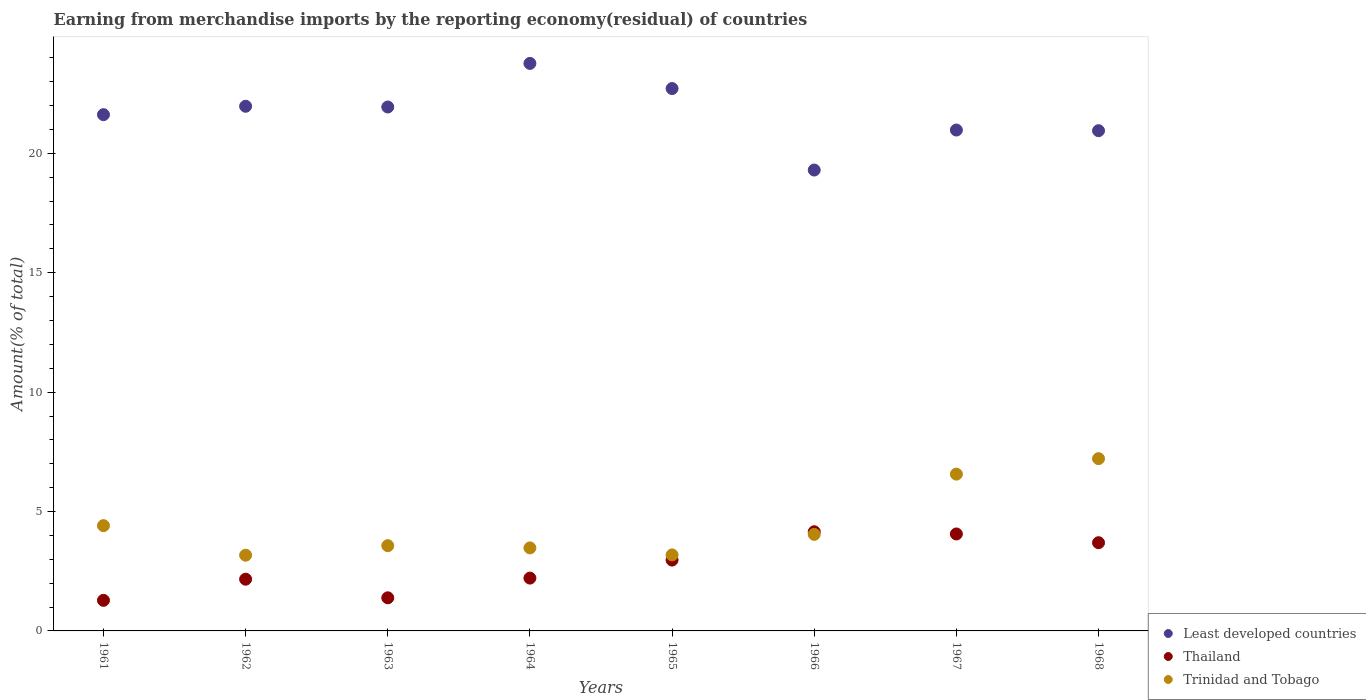How many different coloured dotlines are there?
Make the answer very short. 3. Is the number of dotlines equal to the number of legend labels?
Ensure brevity in your answer.  Yes. What is the percentage of amount earned from merchandise imports in Least developed countries in 1968?
Make the answer very short. 20.95. Across all years, what is the maximum percentage of amount earned from merchandise imports in Trinidad and Tobago?
Your response must be concise. 7.21. Across all years, what is the minimum percentage of amount earned from merchandise imports in Least developed countries?
Keep it short and to the point. 19.3. In which year was the percentage of amount earned from merchandise imports in Trinidad and Tobago maximum?
Your response must be concise. 1968. What is the total percentage of amount earned from merchandise imports in Thailand in the graph?
Give a very brief answer. 21.92. What is the difference between the percentage of amount earned from merchandise imports in Least developed countries in 1961 and that in 1966?
Your answer should be compact. 2.32. What is the difference between the percentage of amount earned from merchandise imports in Least developed countries in 1967 and the percentage of amount earned from merchandise imports in Trinidad and Tobago in 1968?
Your response must be concise. 13.76. What is the average percentage of amount earned from merchandise imports in Least developed countries per year?
Your response must be concise. 21.65. In the year 1961, what is the difference between the percentage of amount earned from merchandise imports in Least developed countries and percentage of amount earned from merchandise imports in Trinidad and Tobago?
Your answer should be compact. 17.21. What is the ratio of the percentage of amount earned from merchandise imports in Thailand in 1965 to that in 1968?
Your answer should be compact. 0.8. Is the difference between the percentage of amount earned from merchandise imports in Least developed countries in 1965 and 1967 greater than the difference between the percentage of amount earned from merchandise imports in Trinidad and Tobago in 1965 and 1967?
Your answer should be compact. Yes. What is the difference between the highest and the second highest percentage of amount earned from merchandise imports in Trinidad and Tobago?
Make the answer very short. 0.65. What is the difference between the highest and the lowest percentage of amount earned from merchandise imports in Thailand?
Offer a very short reply. 2.87. In how many years, is the percentage of amount earned from merchandise imports in Thailand greater than the average percentage of amount earned from merchandise imports in Thailand taken over all years?
Your answer should be very brief. 4. Is the sum of the percentage of amount earned from merchandise imports in Thailand in 1963 and 1965 greater than the maximum percentage of amount earned from merchandise imports in Trinidad and Tobago across all years?
Make the answer very short. No. Does the percentage of amount earned from merchandise imports in Trinidad and Tobago monotonically increase over the years?
Provide a succinct answer. No. How many dotlines are there?
Your answer should be very brief. 3. Does the graph contain any zero values?
Ensure brevity in your answer.  No. How are the legend labels stacked?
Provide a succinct answer. Vertical. What is the title of the graph?
Give a very brief answer. Earning from merchandise imports by the reporting economy(residual) of countries. Does "Liechtenstein" appear as one of the legend labels in the graph?
Offer a terse response. No. What is the label or title of the Y-axis?
Your answer should be very brief. Amount(% of total). What is the Amount(% of total) in Least developed countries in 1961?
Your response must be concise. 21.62. What is the Amount(% of total) of Thailand in 1961?
Offer a terse response. 1.28. What is the Amount(% of total) of Trinidad and Tobago in 1961?
Make the answer very short. 4.41. What is the Amount(% of total) in Least developed countries in 1962?
Provide a short and direct response. 21.97. What is the Amount(% of total) of Thailand in 1962?
Offer a terse response. 2.17. What is the Amount(% of total) in Trinidad and Tobago in 1962?
Your answer should be compact. 3.17. What is the Amount(% of total) in Least developed countries in 1963?
Offer a very short reply. 21.94. What is the Amount(% of total) in Thailand in 1963?
Offer a terse response. 1.39. What is the Amount(% of total) of Trinidad and Tobago in 1963?
Make the answer very short. 3.57. What is the Amount(% of total) of Least developed countries in 1964?
Ensure brevity in your answer.  23.77. What is the Amount(% of total) of Thailand in 1964?
Ensure brevity in your answer.  2.21. What is the Amount(% of total) of Trinidad and Tobago in 1964?
Make the answer very short. 3.48. What is the Amount(% of total) of Least developed countries in 1965?
Offer a very short reply. 22.71. What is the Amount(% of total) in Thailand in 1965?
Keep it short and to the point. 2.97. What is the Amount(% of total) in Trinidad and Tobago in 1965?
Give a very brief answer. 3.18. What is the Amount(% of total) in Least developed countries in 1966?
Provide a succinct answer. 19.3. What is the Amount(% of total) in Thailand in 1966?
Your answer should be very brief. 4.15. What is the Amount(% of total) of Trinidad and Tobago in 1966?
Ensure brevity in your answer.  4.04. What is the Amount(% of total) in Least developed countries in 1967?
Ensure brevity in your answer.  20.98. What is the Amount(% of total) in Thailand in 1967?
Provide a short and direct response. 4.06. What is the Amount(% of total) of Trinidad and Tobago in 1967?
Offer a very short reply. 6.57. What is the Amount(% of total) in Least developed countries in 1968?
Offer a terse response. 20.95. What is the Amount(% of total) in Thailand in 1968?
Make the answer very short. 3.69. What is the Amount(% of total) of Trinidad and Tobago in 1968?
Provide a short and direct response. 7.21. Across all years, what is the maximum Amount(% of total) of Least developed countries?
Provide a short and direct response. 23.77. Across all years, what is the maximum Amount(% of total) in Thailand?
Make the answer very short. 4.15. Across all years, what is the maximum Amount(% of total) in Trinidad and Tobago?
Offer a terse response. 7.21. Across all years, what is the minimum Amount(% of total) of Least developed countries?
Provide a succinct answer. 19.3. Across all years, what is the minimum Amount(% of total) in Thailand?
Your answer should be very brief. 1.28. Across all years, what is the minimum Amount(% of total) in Trinidad and Tobago?
Keep it short and to the point. 3.17. What is the total Amount(% of total) of Least developed countries in the graph?
Provide a succinct answer. 173.23. What is the total Amount(% of total) of Thailand in the graph?
Your answer should be very brief. 21.92. What is the total Amount(% of total) of Trinidad and Tobago in the graph?
Offer a very short reply. 35.63. What is the difference between the Amount(% of total) in Least developed countries in 1961 and that in 1962?
Keep it short and to the point. -0.35. What is the difference between the Amount(% of total) in Thailand in 1961 and that in 1962?
Your response must be concise. -0.89. What is the difference between the Amount(% of total) of Trinidad and Tobago in 1961 and that in 1962?
Your answer should be compact. 1.24. What is the difference between the Amount(% of total) of Least developed countries in 1961 and that in 1963?
Your answer should be very brief. -0.32. What is the difference between the Amount(% of total) in Thailand in 1961 and that in 1963?
Your answer should be very brief. -0.11. What is the difference between the Amount(% of total) in Trinidad and Tobago in 1961 and that in 1963?
Provide a short and direct response. 0.84. What is the difference between the Amount(% of total) of Least developed countries in 1961 and that in 1964?
Provide a succinct answer. -2.15. What is the difference between the Amount(% of total) of Thailand in 1961 and that in 1964?
Ensure brevity in your answer.  -0.93. What is the difference between the Amount(% of total) in Trinidad and Tobago in 1961 and that in 1964?
Your answer should be very brief. 0.93. What is the difference between the Amount(% of total) of Least developed countries in 1961 and that in 1965?
Ensure brevity in your answer.  -1.09. What is the difference between the Amount(% of total) in Thailand in 1961 and that in 1965?
Make the answer very short. -1.69. What is the difference between the Amount(% of total) of Trinidad and Tobago in 1961 and that in 1965?
Your answer should be compact. 1.23. What is the difference between the Amount(% of total) of Least developed countries in 1961 and that in 1966?
Offer a very short reply. 2.32. What is the difference between the Amount(% of total) in Thailand in 1961 and that in 1966?
Your answer should be very brief. -2.87. What is the difference between the Amount(% of total) of Trinidad and Tobago in 1961 and that in 1966?
Ensure brevity in your answer.  0.37. What is the difference between the Amount(% of total) of Least developed countries in 1961 and that in 1967?
Offer a very short reply. 0.64. What is the difference between the Amount(% of total) in Thailand in 1961 and that in 1967?
Your answer should be compact. -2.78. What is the difference between the Amount(% of total) in Trinidad and Tobago in 1961 and that in 1967?
Your answer should be compact. -2.16. What is the difference between the Amount(% of total) of Least developed countries in 1961 and that in 1968?
Your answer should be compact. 0.67. What is the difference between the Amount(% of total) in Thailand in 1961 and that in 1968?
Ensure brevity in your answer.  -2.41. What is the difference between the Amount(% of total) of Trinidad and Tobago in 1961 and that in 1968?
Provide a succinct answer. -2.81. What is the difference between the Amount(% of total) in Least developed countries in 1962 and that in 1963?
Offer a very short reply. 0.03. What is the difference between the Amount(% of total) in Thailand in 1962 and that in 1963?
Offer a terse response. 0.78. What is the difference between the Amount(% of total) in Trinidad and Tobago in 1962 and that in 1963?
Provide a succinct answer. -0.4. What is the difference between the Amount(% of total) in Least developed countries in 1962 and that in 1964?
Offer a very short reply. -1.79. What is the difference between the Amount(% of total) of Thailand in 1962 and that in 1964?
Offer a very short reply. -0.05. What is the difference between the Amount(% of total) of Trinidad and Tobago in 1962 and that in 1964?
Provide a short and direct response. -0.31. What is the difference between the Amount(% of total) of Least developed countries in 1962 and that in 1965?
Your answer should be very brief. -0.74. What is the difference between the Amount(% of total) in Thailand in 1962 and that in 1965?
Offer a terse response. -0.8. What is the difference between the Amount(% of total) in Trinidad and Tobago in 1962 and that in 1965?
Your answer should be compact. -0.01. What is the difference between the Amount(% of total) of Least developed countries in 1962 and that in 1966?
Offer a terse response. 2.67. What is the difference between the Amount(% of total) in Thailand in 1962 and that in 1966?
Your answer should be very brief. -1.99. What is the difference between the Amount(% of total) of Trinidad and Tobago in 1962 and that in 1966?
Make the answer very short. -0.87. What is the difference between the Amount(% of total) in Least developed countries in 1962 and that in 1967?
Keep it short and to the point. 1. What is the difference between the Amount(% of total) of Thailand in 1962 and that in 1967?
Your answer should be compact. -1.89. What is the difference between the Amount(% of total) of Trinidad and Tobago in 1962 and that in 1967?
Offer a terse response. -3.4. What is the difference between the Amount(% of total) in Least developed countries in 1962 and that in 1968?
Ensure brevity in your answer.  1.02. What is the difference between the Amount(% of total) in Thailand in 1962 and that in 1968?
Your response must be concise. -1.53. What is the difference between the Amount(% of total) in Trinidad and Tobago in 1962 and that in 1968?
Ensure brevity in your answer.  -4.04. What is the difference between the Amount(% of total) of Least developed countries in 1963 and that in 1964?
Provide a succinct answer. -1.82. What is the difference between the Amount(% of total) of Thailand in 1963 and that in 1964?
Provide a short and direct response. -0.83. What is the difference between the Amount(% of total) in Trinidad and Tobago in 1963 and that in 1964?
Make the answer very short. 0.09. What is the difference between the Amount(% of total) of Least developed countries in 1963 and that in 1965?
Keep it short and to the point. -0.77. What is the difference between the Amount(% of total) of Thailand in 1963 and that in 1965?
Offer a very short reply. -1.58. What is the difference between the Amount(% of total) in Trinidad and Tobago in 1963 and that in 1965?
Make the answer very short. 0.39. What is the difference between the Amount(% of total) of Least developed countries in 1963 and that in 1966?
Provide a succinct answer. 2.64. What is the difference between the Amount(% of total) of Thailand in 1963 and that in 1966?
Give a very brief answer. -2.77. What is the difference between the Amount(% of total) in Trinidad and Tobago in 1963 and that in 1966?
Provide a succinct answer. -0.47. What is the difference between the Amount(% of total) of Least developed countries in 1963 and that in 1967?
Your response must be concise. 0.96. What is the difference between the Amount(% of total) of Thailand in 1963 and that in 1967?
Make the answer very short. -2.67. What is the difference between the Amount(% of total) in Trinidad and Tobago in 1963 and that in 1967?
Your answer should be very brief. -3. What is the difference between the Amount(% of total) of Thailand in 1963 and that in 1968?
Keep it short and to the point. -2.31. What is the difference between the Amount(% of total) of Trinidad and Tobago in 1963 and that in 1968?
Your response must be concise. -3.64. What is the difference between the Amount(% of total) of Least developed countries in 1964 and that in 1965?
Give a very brief answer. 1.05. What is the difference between the Amount(% of total) in Thailand in 1964 and that in 1965?
Make the answer very short. -0.75. What is the difference between the Amount(% of total) of Trinidad and Tobago in 1964 and that in 1965?
Your answer should be compact. 0.29. What is the difference between the Amount(% of total) of Least developed countries in 1964 and that in 1966?
Ensure brevity in your answer.  4.46. What is the difference between the Amount(% of total) of Thailand in 1964 and that in 1966?
Offer a terse response. -1.94. What is the difference between the Amount(% of total) of Trinidad and Tobago in 1964 and that in 1966?
Your response must be concise. -0.57. What is the difference between the Amount(% of total) of Least developed countries in 1964 and that in 1967?
Offer a terse response. 2.79. What is the difference between the Amount(% of total) in Thailand in 1964 and that in 1967?
Provide a succinct answer. -1.85. What is the difference between the Amount(% of total) in Trinidad and Tobago in 1964 and that in 1967?
Your answer should be compact. -3.09. What is the difference between the Amount(% of total) in Least developed countries in 1964 and that in 1968?
Offer a very short reply. 2.82. What is the difference between the Amount(% of total) in Thailand in 1964 and that in 1968?
Provide a succinct answer. -1.48. What is the difference between the Amount(% of total) of Trinidad and Tobago in 1964 and that in 1968?
Provide a short and direct response. -3.74. What is the difference between the Amount(% of total) in Least developed countries in 1965 and that in 1966?
Give a very brief answer. 3.41. What is the difference between the Amount(% of total) in Thailand in 1965 and that in 1966?
Offer a terse response. -1.19. What is the difference between the Amount(% of total) in Trinidad and Tobago in 1965 and that in 1966?
Your answer should be very brief. -0.86. What is the difference between the Amount(% of total) of Least developed countries in 1965 and that in 1967?
Ensure brevity in your answer.  1.74. What is the difference between the Amount(% of total) of Thailand in 1965 and that in 1967?
Your answer should be compact. -1.09. What is the difference between the Amount(% of total) of Trinidad and Tobago in 1965 and that in 1967?
Make the answer very short. -3.38. What is the difference between the Amount(% of total) of Least developed countries in 1965 and that in 1968?
Your answer should be very brief. 1.77. What is the difference between the Amount(% of total) in Thailand in 1965 and that in 1968?
Offer a terse response. -0.73. What is the difference between the Amount(% of total) of Trinidad and Tobago in 1965 and that in 1968?
Keep it short and to the point. -4.03. What is the difference between the Amount(% of total) in Least developed countries in 1966 and that in 1967?
Keep it short and to the point. -1.67. What is the difference between the Amount(% of total) of Thailand in 1966 and that in 1967?
Make the answer very short. 0.09. What is the difference between the Amount(% of total) of Trinidad and Tobago in 1966 and that in 1967?
Provide a short and direct response. -2.52. What is the difference between the Amount(% of total) of Least developed countries in 1966 and that in 1968?
Provide a succinct answer. -1.65. What is the difference between the Amount(% of total) in Thailand in 1966 and that in 1968?
Your answer should be compact. 0.46. What is the difference between the Amount(% of total) in Trinidad and Tobago in 1966 and that in 1968?
Provide a succinct answer. -3.17. What is the difference between the Amount(% of total) of Least developed countries in 1967 and that in 1968?
Your answer should be very brief. 0.03. What is the difference between the Amount(% of total) in Thailand in 1967 and that in 1968?
Offer a very short reply. 0.37. What is the difference between the Amount(% of total) of Trinidad and Tobago in 1967 and that in 1968?
Your answer should be compact. -0.65. What is the difference between the Amount(% of total) of Least developed countries in 1961 and the Amount(% of total) of Thailand in 1962?
Offer a terse response. 19.45. What is the difference between the Amount(% of total) in Least developed countries in 1961 and the Amount(% of total) in Trinidad and Tobago in 1962?
Offer a very short reply. 18.45. What is the difference between the Amount(% of total) of Thailand in 1961 and the Amount(% of total) of Trinidad and Tobago in 1962?
Provide a short and direct response. -1.89. What is the difference between the Amount(% of total) of Least developed countries in 1961 and the Amount(% of total) of Thailand in 1963?
Offer a very short reply. 20.23. What is the difference between the Amount(% of total) of Least developed countries in 1961 and the Amount(% of total) of Trinidad and Tobago in 1963?
Your answer should be very brief. 18.05. What is the difference between the Amount(% of total) of Thailand in 1961 and the Amount(% of total) of Trinidad and Tobago in 1963?
Ensure brevity in your answer.  -2.29. What is the difference between the Amount(% of total) of Least developed countries in 1961 and the Amount(% of total) of Thailand in 1964?
Keep it short and to the point. 19.41. What is the difference between the Amount(% of total) in Least developed countries in 1961 and the Amount(% of total) in Trinidad and Tobago in 1964?
Make the answer very short. 18.14. What is the difference between the Amount(% of total) of Thailand in 1961 and the Amount(% of total) of Trinidad and Tobago in 1964?
Make the answer very short. -2.2. What is the difference between the Amount(% of total) in Least developed countries in 1961 and the Amount(% of total) in Thailand in 1965?
Make the answer very short. 18.65. What is the difference between the Amount(% of total) of Least developed countries in 1961 and the Amount(% of total) of Trinidad and Tobago in 1965?
Give a very brief answer. 18.44. What is the difference between the Amount(% of total) in Thailand in 1961 and the Amount(% of total) in Trinidad and Tobago in 1965?
Offer a terse response. -1.9. What is the difference between the Amount(% of total) in Least developed countries in 1961 and the Amount(% of total) in Thailand in 1966?
Offer a very short reply. 17.47. What is the difference between the Amount(% of total) in Least developed countries in 1961 and the Amount(% of total) in Trinidad and Tobago in 1966?
Offer a very short reply. 17.58. What is the difference between the Amount(% of total) of Thailand in 1961 and the Amount(% of total) of Trinidad and Tobago in 1966?
Offer a terse response. -2.76. What is the difference between the Amount(% of total) in Least developed countries in 1961 and the Amount(% of total) in Thailand in 1967?
Offer a very short reply. 17.56. What is the difference between the Amount(% of total) in Least developed countries in 1961 and the Amount(% of total) in Trinidad and Tobago in 1967?
Make the answer very short. 15.05. What is the difference between the Amount(% of total) in Thailand in 1961 and the Amount(% of total) in Trinidad and Tobago in 1967?
Ensure brevity in your answer.  -5.29. What is the difference between the Amount(% of total) of Least developed countries in 1961 and the Amount(% of total) of Thailand in 1968?
Offer a terse response. 17.93. What is the difference between the Amount(% of total) of Least developed countries in 1961 and the Amount(% of total) of Trinidad and Tobago in 1968?
Provide a short and direct response. 14.41. What is the difference between the Amount(% of total) of Thailand in 1961 and the Amount(% of total) of Trinidad and Tobago in 1968?
Ensure brevity in your answer.  -5.93. What is the difference between the Amount(% of total) in Least developed countries in 1962 and the Amount(% of total) in Thailand in 1963?
Ensure brevity in your answer.  20.58. What is the difference between the Amount(% of total) in Least developed countries in 1962 and the Amount(% of total) in Trinidad and Tobago in 1963?
Your answer should be compact. 18.4. What is the difference between the Amount(% of total) of Thailand in 1962 and the Amount(% of total) of Trinidad and Tobago in 1963?
Offer a very short reply. -1.4. What is the difference between the Amount(% of total) in Least developed countries in 1962 and the Amount(% of total) in Thailand in 1964?
Offer a very short reply. 19.76. What is the difference between the Amount(% of total) of Least developed countries in 1962 and the Amount(% of total) of Trinidad and Tobago in 1964?
Ensure brevity in your answer.  18.49. What is the difference between the Amount(% of total) in Thailand in 1962 and the Amount(% of total) in Trinidad and Tobago in 1964?
Your response must be concise. -1.31. What is the difference between the Amount(% of total) in Least developed countries in 1962 and the Amount(% of total) in Thailand in 1965?
Offer a very short reply. 19. What is the difference between the Amount(% of total) in Least developed countries in 1962 and the Amount(% of total) in Trinidad and Tobago in 1965?
Give a very brief answer. 18.79. What is the difference between the Amount(% of total) of Thailand in 1962 and the Amount(% of total) of Trinidad and Tobago in 1965?
Give a very brief answer. -1.02. What is the difference between the Amount(% of total) of Least developed countries in 1962 and the Amount(% of total) of Thailand in 1966?
Provide a succinct answer. 17.82. What is the difference between the Amount(% of total) in Least developed countries in 1962 and the Amount(% of total) in Trinidad and Tobago in 1966?
Provide a short and direct response. 17.93. What is the difference between the Amount(% of total) of Thailand in 1962 and the Amount(% of total) of Trinidad and Tobago in 1966?
Make the answer very short. -1.88. What is the difference between the Amount(% of total) in Least developed countries in 1962 and the Amount(% of total) in Thailand in 1967?
Provide a short and direct response. 17.91. What is the difference between the Amount(% of total) of Least developed countries in 1962 and the Amount(% of total) of Trinidad and Tobago in 1967?
Your answer should be compact. 15.4. What is the difference between the Amount(% of total) of Thailand in 1962 and the Amount(% of total) of Trinidad and Tobago in 1967?
Offer a terse response. -4.4. What is the difference between the Amount(% of total) in Least developed countries in 1962 and the Amount(% of total) in Thailand in 1968?
Offer a terse response. 18.28. What is the difference between the Amount(% of total) of Least developed countries in 1962 and the Amount(% of total) of Trinidad and Tobago in 1968?
Make the answer very short. 14.76. What is the difference between the Amount(% of total) in Thailand in 1962 and the Amount(% of total) in Trinidad and Tobago in 1968?
Offer a terse response. -5.05. What is the difference between the Amount(% of total) in Least developed countries in 1963 and the Amount(% of total) in Thailand in 1964?
Your response must be concise. 19.73. What is the difference between the Amount(% of total) in Least developed countries in 1963 and the Amount(% of total) in Trinidad and Tobago in 1964?
Keep it short and to the point. 18.46. What is the difference between the Amount(% of total) of Thailand in 1963 and the Amount(% of total) of Trinidad and Tobago in 1964?
Your response must be concise. -2.09. What is the difference between the Amount(% of total) in Least developed countries in 1963 and the Amount(% of total) in Thailand in 1965?
Ensure brevity in your answer.  18.97. What is the difference between the Amount(% of total) in Least developed countries in 1963 and the Amount(% of total) in Trinidad and Tobago in 1965?
Your response must be concise. 18.76. What is the difference between the Amount(% of total) of Thailand in 1963 and the Amount(% of total) of Trinidad and Tobago in 1965?
Offer a terse response. -1.8. What is the difference between the Amount(% of total) of Least developed countries in 1963 and the Amount(% of total) of Thailand in 1966?
Make the answer very short. 17.79. What is the difference between the Amount(% of total) of Least developed countries in 1963 and the Amount(% of total) of Trinidad and Tobago in 1966?
Offer a very short reply. 17.9. What is the difference between the Amount(% of total) of Thailand in 1963 and the Amount(% of total) of Trinidad and Tobago in 1966?
Keep it short and to the point. -2.66. What is the difference between the Amount(% of total) of Least developed countries in 1963 and the Amount(% of total) of Thailand in 1967?
Keep it short and to the point. 17.88. What is the difference between the Amount(% of total) in Least developed countries in 1963 and the Amount(% of total) in Trinidad and Tobago in 1967?
Offer a very short reply. 15.37. What is the difference between the Amount(% of total) in Thailand in 1963 and the Amount(% of total) in Trinidad and Tobago in 1967?
Your answer should be very brief. -5.18. What is the difference between the Amount(% of total) in Least developed countries in 1963 and the Amount(% of total) in Thailand in 1968?
Offer a very short reply. 18.25. What is the difference between the Amount(% of total) of Least developed countries in 1963 and the Amount(% of total) of Trinidad and Tobago in 1968?
Offer a very short reply. 14.73. What is the difference between the Amount(% of total) in Thailand in 1963 and the Amount(% of total) in Trinidad and Tobago in 1968?
Keep it short and to the point. -5.83. What is the difference between the Amount(% of total) in Least developed countries in 1964 and the Amount(% of total) in Thailand in 1965?
Give a very brief answer. 20.8. What is the difference between the Amount(% of total) in Least developed countries in 1964 and the Amount(% of total) in Trinidad and Tobago in 1965?
Offer a very short reply. 20.58. What is the difference between the Amount(% of total) of Thailand in 1964 and the Amount(% of total) of Trinidad and Tobago in 1965?
Your response must be concise. -0.97. What is the difference between the Amount(% of total) of Least developed countries in 1964 and the Amount(% of total) of Thailand in 1966?
Provide a succinct answer. 19.61. What is the difference between the Amount(% of total) in Least developed countries in 1964 and the Amount(% of total) in Trinidad and Tobago in 1966?
Offer a terse response. 19.72. What is the difference between the Amount(% of total) in Thailand in 1964 and the Amount(% of total) in Trinidad and Tobago in 1966?
Provide a short and direct response. -1.83. What is the difference between the Amount(% of total) of Least developed countries in 1964 and the Amount(% of total) of Thailand in 1967?
Your response must be concise. 19.71. What is the difference between the Amount(% of total) of Least developed countries in 1964 and the Amount(% of total) of Trinidad and Tobago in 1967?
Your answer should be very brief. 17.2. What is the difference between the Amount(% of total) of Thailand in 1964 and the Amount(% of total) of Trinidad and Tobago in 1967?
Offer a terse response. -4.35. What is the difference between the Amount(% of total) in Least developed countries in 1964 and the Amount(% of total) in Thailand in 1968?
Ensure brevity in your answer.  20.07. What is the difference between the Amount(% of total) of Least developed countries in 1964 and the Amount(% of total) of Trinidad and Tobago in 1968?
Your answer should be compact. 16.55. What is the difference between the Amount(% of total) in Thailand in 1964 and the Amount(% of total) in Trinidad and Tobago in 1968?
Keep it short and to the point. -5. What is the difference between the Amount(% of total) in Least developed countries in 1965 and the Amount(% of total) in Thailand in 1966?
Offer a terse response. 18.56. What is the difference between the Amount(% of total) in Least developed countries in 1965 and the Amount(% of total) in Trinidad and Tobago in 1966?
Offer a very short reply. 18.67. What is the difference between the Amount(% of total) in Thailand in 1965 and the Amount(% of total) in Trinidad and Tobago in 1966?
Your answer should be compact. -1.08. What is the difference between the Amount(% of total) of Least developed countries in 1965 and the Amount(% of total) of Thailand in 1967?
Your response must be concise. 18.65. What is the difference between the Amount(% of total) in Least developed countries in 1965 and the Amount(% of total) in Trinidad and Tobago in 1967?
Provide a short and direct response. 16.15. What is the difference between the Amount(% of total) in Thailand in 1965 and the Amount(% of total) in Trinidad and Tobago in 1967?
Make the answer very short. -3.6. What is the difference between the Amount(% of total) of Least developed countries in 1965 and the Amount(% of total) of Thailand in 1968?
Provide a short and direct response. 19.02. What is the difference between the Amount(% of total) of Least developed countries in 1965 and the Amount(% of total) of Trinidad and Tobago in 1968?
Provide a short and direct response. 15.5. What is the difference between the Amount(% of total) of Thailand in 1965 and the Amount(% of total) of Trinidad and Tobago in 1968?
Provide a short and direct response. -4.25. What is the difference between the Amount(% of total) in Least developed countries in 1966 and the Amount(% of total) in Thailand in 1967?
Give a very brief answer. 15.24. What is the difference between the Amount(% of total) in Least developed countries in 1966 and the Amount(% of total) in Trinidad and Tobago in 1967?
Your response must be concise. 12.73. What is the difference between the Amount(% of total) in Thailand in 1966 and the Amount(% of total) in Trinidad and Tobago in 1967?
Keep it short and to the point. -2.41. What is the difference between the Amount(% of total) in Least developed countries in 1966 and the Amount(% of total) in Thailand in 1968?
Keep it short and to the point. 15.61. What is the difference between the Amount(% of total) of Least developed countries in 1966 and the Amount(% of total) of Trinidad and Tobago in 1968?
Your answer should be very brief. 12.09. What is the difference between the Amount(% of total) in Thailand in 1966 and the Amount(% of total) in Trinidad and Tobago in 1968?
Make the answer very short. -3.06. What is the difference between the Amount(% of total) in Least developed countries in 1967 and the Amount(% of total) in Thailand in 1968?
Provide a succinct answer. 17.28. What is the difference between the Amount(% of total) of Least developed countries in 1967 and the Amount(% of total) of Trinidad and Tobago in 1968?
Make the answer very short. 13.76. What is the difference between the Amount(% of total) in Thailand in 1967 and the Amount(% of total) in Trinidad and Tobago in 1968?
Provide a short and direct response. -3.15. What is the average Amount(% of total) of Least developed countries per year?
Give a very brief answer. 21.65. What is the average Amount(% of total) of Thailand per year?
Provide a short and direct response. 2.74. What is the average Amount(% of total) of Trinidad and Tobago per year?
Your answer should be very brief. 4.45. In the year 1961, what is the difference between the Amount(% of total) of Least developed countries and Amount(% of total) of Thailand?
Offer a very short reply. 20.34. In the year 1961, what is the difference between the Amount(% of total) of Least developed countries and Amount(% of total) of Trinidad and Tobago?
Offer a terse response. 17.21. In the year 1961, what is the difference between the Amount(% of total) of Thailand and Amount(% of total) of Trinidad and Tobago?
Give a very brief answer. -3.13. In the year 1962, what is the difference between the Amount(% of total) in Least developed countries and Amount(% of total) in Thailand?
Offer a very short reply. 19.8. In the year 1962, what is the difference between the Amount(% of total) in Least developed countries and Amount(% of total) in Trinidad and Tobago?
Make the answer very short. 18.8. In the year 1962, what is the difference between the Amount(% of total) of Thailand and Amount(% of total) of Trinidad and Tobago?
Provide a short and direct response. -1. In the year 1963, what is the difference between the Amount(% of total) in Least developed countries and Amount(% of total) in Thailand?
Your answer should be compact. 20.55. In the year 1963, what is the difference between the Amount(% of total) in Least developed countries and Amount(% of total) in Trinidad and Tobago?
Keep it short and to the point. 18.37. In the year 1963, what is the difference between the Amount(% of total) in Thailand and Amount(% of total) in Trinidad and Tobago?
Your answer should be very brief. -2.18. In the year 1964, what is the difference between the Amount(% of total) in Least developed countries and Amount(% of total) in Thailand?
Give a very brief answer. 21.55. In the year 1964, what is the difference between the Amount(% of total) of Least developed countries and Amount(% of total) of Trinidad and Tobago?
Ensure brevity in your answer.  20.29. In the year 1964, what is the difference between the Amount(% of total) in Thailand and Amount(% of total) in Trinidad and Tobago?
Make the answer very short. -1.26. In the year 1965, what is the difference between the Amount(% of total) of Least developed countries and Amount(% of total) of Thailand?
Provide a short and direct response. 19.75. In the year 1965, what is the difference between the Amount(% of total) in Least developed countries and Amount(% of total) in Trinidad and Tobago?
Make the answer very short. 19.53. In the year 1965, what is the difference between the Amount(% of total) in Thailand and Amount(% of total) in Trinidad and Tobago?
Offer a very short reply. -0.22. In the year 1966, what is the difference between the Amount(% of total) of Least developed countries and Amount(% of total) of Thailand?
Your answer should be very brief. 15.15. In the year 1966, what is the difference between the Amount(% of total) of Least developed countries and Amount(% of total) of Trinidad and Tobago?
Your answer should be compact. 15.26. In the year 1966, what is the difference between the Amount(% of total) in Thailand and Amount(% of total) in Trinidad and Tobago?
Keep it short and to the point. 0.11. In the year 1967, what is the difference between the Amount(% of total) in Least developed countries and Amount(% of total) in Thailand?
Your answer should be very brief. 16.92. In the year 1967, what is the difference between the Amount(% of total) of Least developed countries and Amount(% of total) of Trinidad and Tobago?
Provide a short and direct response. 14.41. In the year 1967, what is the difference between the Amount(% of total) of Thailand and Amount(% of total) of Trinidad and Tobago?
Your response must be concise. -2.51. In the year 1968, what is the difference between the Amount(% of total) in Least developed countries and Amount(% of total) in Thailand?
Offer a terse response. 17.25. In the year 1968, what is the difference between the Amount(% of total) of Least developed countries and Amount(% of total) of Trinidad and Tobago?
Keep it short and to the point. 13.73. In the year 1968, what is the difference between the Amount(% of total) in Thailand and Amount(% of total) in Trinidad and Tobago?
Ensure brevity in your answer.  -3.52. What is the ratio of the Amount(% of total) in Least developed countries in 1961 to that in 1962?
Your answer should be very brief. 0.98. What is the ratio of the Amount(% of total) of Thailand in 1961 to that in 1962?
Your answer should be very brief. 0.59. What is the ratio of the Amount(% of total) of Trinidad and Tobago in 1961 to that in 1962?
Give a very brief answer. 1.39. What is the ratio of the Amount(% of total) in Least developed countries in 1961 to that in 1963?
Provide a short and direct response. 0.99. What is the ratio of the Amount(% of total) in Thailand in 1961 to that in 1963?
Your answer should be very brief. 0.92. What is the ratio of the Amount(% of total) of Trinidad and Tobago in 1961 to that in 1963?
Offer a very short reply. 1.24. What is the ratio of the Amount(% of total) of Least developed countries in 1961 to that in 1964?
Ensure brevity in your answer.  0.91. What is the ratio of the Amount(% of total) of Thailand in 1961 to that in 1964?
Ensure brevity in your answer.  0.58. What is the ratio of the Amount(% of total) of Trinidad and Tobago in 1961 to that in 1964?
Give a very brief answer. 1.27. What is the ratio of the Amount(% of total) of Least developed countries in 1961 to that in 1965?
Ensure brevity in your answer.  0.95. What is the ratio of the Amount(% of total) in Thailand in 1961 to that in 1965?
Provide a short and direct response. 0.43. What is the ratio of the Amount(% of total) in Trinidad and Tobago in 1961 to that in 1965?
Your answer should be very brief. 1.39. What is the ratio of the Amount(% of total) of Least developed countries in 1961 to that in 1966?
Make the answer very short. 1.12. What is the ratio of the Amount(% of total) in Thailand in 1961 to that in 1966?
Offer a very short reply. 0.31. What is the ratio of the Amount(% of total) in Trinidad and Tobago in 1961 to that in 1966?
Provide a succinct answer. 1.09. What is the ratio of the Amount(% of total) of Least developed countries in 1961 to that in 1967?
Offer a terse response. 1.03. What is the ratio of the Amount(% of total) of Thailand in 1961 to that in 1967?
Your response must be concise. 0.32. What is the ratio of the Amount(% of total) of Trinidad and Tobago in 1961 to that in 1967?
Offer a very short reply. 0.67. What is the ratio of the Amount(% of total) in Least developed countries in 1961 to that in 1968?
Ensure brevity in your answer.  1.03. What is the ratio of the Amount(% of total) of Thailand in 1961 to that in 1968?
Provide a short and direct response. 0.35. What is the ratio of the Amount(% of total) in Trinidad and Tobago in 1961 to that in 1968?
Your answer should be very brief. 0.61. What is the ratio of the Amount(% of total) of Least developed countries in 1962 to that in 1963?
Offer a terse response. 1. What is the ratio of the Amount(% of total) of Thailand in 1962 to that in 1963?
Offer a terse response. 1.56. What is the ratio of the Amount(% of total) of Trinidad and Tobago in 1962 to that in 1963?
Your answer should be compact. 0.89. What is the ratio of the Amount(% of total) of Least developed countries in 1962 to that in 1964?
Your answer should be compact. 0.92. What is the ratio of the Amount(% of total) of Thailand in 1962 to that in 1964?
Your response must be concise. 0.98. What is the ratio of the Amount(% of total) in Trinidad and Tobago in 1962 to that in 1964?
Ensure brevity in your answer.  0.91. What is the ratio of the Amount(% of total) in Least developed countries in 1962 to that in 1965?
Keep it short and to the point. 0.97. What is the ratio of the Amount(% of total) of Thailand in 1962 to that in 1965?
Keep it short and to the point. 0.73. What is the ratio of the Amount(% of total) in Trinidad and Tobago in 1962 to that in 1965?
Ensure brevity in your answer.  1. What is the ratio of the Amount(% of total) of Least developed countries in 1962 to that in 1966?
Your answer should be very brief. 1.14. What is the ratio of the Amount(% of total) in Thailand in 1962 to that in 1966?
Provide a short and direct response. 0.52. What is the ratio of the Amount(% of total) in Trinidad and Tobago in 1962 to that in 1966?
Offer a terse response. 0.78. What is the ratio of the Amount(% of total) of Least developed countries in 1962 to that in 1967?
Your response must be concise. 1.05. What is the ratio of the Amount(% of total) in Thailand in 1962 to that in 1967?
Provide a short and direct response. 0.53. What is the ratio of the Amount(% of total) in Trinidad and Tobago in 1962 to that in 1967?
Ensure brevity in your answer.  0.48. What is the ratio of the Amount(% of total) of Least developed countries in 1962 to that in 1968?
Make the answer very short. 1.05. What is the ratio of the Amount(% of total) of Thailand in 1962 to that in 1968?
Give a very brief answer. 0.59. What is the ratio of the Amount(% of total) of Trinidad and Tobago in 1962 to that in 1968?
Your answer should be very brief. 0.44. What is the ratio of the Amount(% of total) of Least developed countries in 1963 to that in 1964?
Give a very brief answer. 0.92. What is the ratio of the Amount(% of total) in Thailand in 1963 to that in 1964?
Give a very brief answer. 0.63. What is the ratio of the Amount(% of total) in Trinidad and Tobago in 1963 to that in 1964?
Keep it short and to the point. 1.03. What is the ratio of the Amount(% of total) of Thailand in 1963 to that in 1965?
Ensure brevity in your answer.  0.47. What is the ratio of the Amount(% of total) in Trinidad and Tobago in 1963 to that in 1965?
Keep it short and to the point. 1.12. What is the ratio of the Amount(% of total) in Least developed countries in 1963 to that in 1966?
Keep it short and to the point. 1.14. What is the ratio of the Amount(% of total) of Thailand in 1963 to that in 1966?
Offer a terse response. 0.33. What is the ratio of the Amount(% of total) of Trinidad and Tobago in 1963 to that in 1966?
Your answer should be compact. 0.88. What is the ratio of the Amount(% of total) of Least developed countries in 1963 to that in 1967?
Your answer should be very brief. 1.05. What is the ratio of the Amount(% of total) in Thailand in 1963 to that in 1967?
Your answer should be compact. 0.34. What is the ratio of the Amount(% of total) in Trinidad and Tobago in 1963 to that in 1967?
Ensure brevity in your answer.  0.54. What is the ratio of the Amount(% of total) of Least developed countries in 1963 to that in 1968?
Your answer should be very brief. 1.05. What is the ratio of the Amount(% of total) of Thailand in 1963 to that in 1968?
Offer a terse response. 0.38. What is the ratio of the Amount(% of total) of Trinidad and Tobago in 1963 to that in 1968?
Keep it short and to the point. 0.49. What is the ratio of the Amount(% of total) in Least developed countries in 1964 to that in 1965?
Make the answer very short. 1.05. What is the ratio of the Amount(% of total) in Thailand in 1964 to that in 1965?
Provide a succinct answer. 0.75. What is the ratio of the Amount(% of total) of Trinidad and Tobago in 1964 to that in 1965?
Offer a very short reply. 1.09. What is the ratio of the Amount(% of total) of Least developed countries in 1964 to that in 1966?
Provide a succinct answer. 1.23. What is the ratio of the Amount(% of total) of Thailand in 1964 to that in 1966?
Your answer should be very brief. 0.53. What is the ratio of the Amount(% of total) in Trinidad and Tobago in 1964 to that in 1966?
Make the answer very short. 0.86. What is the ratio of the Amount(% of total) in Least developed countries in 1964 to that in 1967?
Ensure brevity in your answer.  1.13. What is the ratio of the Amount(% of total) of Thailand in 1964 to that in 1967?
Ensure brevity in your answer.  0.54. What is the ratio of the Amount(% of total) in Trinidad and Tobago in 1964 to that in 1967?
Give a very brief answer. 0.53. What is the ratio of the Amount(% of total) in Least developed countries in 1964 to that in 1968?
Offer a terse response. 1.13. What is the ratio of the Amount(% of total) in Thailand in 1964 to that in 1968?
Your answer should be compact. 0.6. What is the ratio of the Amount(% of total) of Trinidad and Tobago in 1964 to that in 1968?
Your answer should be compact. 0.48. What is the ratio of the Amount(% of total) of Least developed countries in 1965 to that in 1966?
Keep it short and to the point. 1.18. What is the ratio of the Amount(% of total) of Thailand in 1965 to that in 1966?
Ensure brevity in your answer.  0.71. What is the ratio of the Amount(% of total) of Trinidad and Tobago in 1965 to that in 1966?
Your answer should be compact. 0.79. What is the ratio of the Amount(% of total) in Least developed countries in 1965 to that in 1967?
Make the answer very short. 1.08. What is the ratio of the Amount(% of total) of Thailand in 1965 to that in 1967?
Give a very brief answer. 0.73. What is the ratio of the Amount(% of total) in Trinidad and Tobago in 1965 to that in 1967?
Your answer should be very brief. 0.48. What is the ratio of the Amount(% of total) in Least developed countries in 1965 to that in 1968?
Keep it short and to the point. 1.08. What is the ratio of the Amount(% of total) in Thailand in 1965 to that in 1968?
Offer a very short reply. 0.8. What is the ratio of the Amount(% of total) of Trinidad and Tobago in 1965 to that in 1968?
Your answer should be compact. 0.44. What is the ratio of the Amount(% of total) in Least developed countries in 1966 to that in 1967?
Offer a terse response. 0.92. What is the ratio of the Amount(% of total) of Thailand in 1966 to that in 1967?
Offer a terse response. 1.02. What is the ratio of the Amount(% of total) in Trinidad and Tobago in 1966 to that in 1967?
Your answer should be very brief. 0.62. What is the ratio of the Amount(% of total) in Least developed countries in 1966 to that in 1968?
Offer a terse response. 0.92. What is the ratio of the Amount(% of total) of Thailand in 1966 to that in 1968?
Offer a very short reply. 1.12. What is the ratio of the Amount(% of total) of Trinidad and Tobago in 1966 to that in 1968?
Make the answer very short. 0.56. What is the ratio of the Amount(% of total) of Thailand in 1967 to that in 1968?
Keep it short and to the point. 1.1. What is the ratio of the Amount(% of total) in Trinidad and Tobago in 1967 to that in 1968?
Ensure brevity in your answer.  0.91. What is the difference between the highest and the second highest Amount(% of total) in Least developed countries?
Offer a terse response. 1.05. What is the difference between the highest and the second highest Amount(% of total) of Thailand?
Your answer should be compact. 0.09. What is the difference between the highest and the second highest Amount(% of total) in Trinidad and Tobago?
Offer a terse response. 0.65. What is the difference between the highest and the lowest Amount(% of total) of Least developed countries?
Offer a terse response. 4.46. What is the difference between the highest and the lowest Amount(% of total) of Thailand?
Your answer should be very brief. 2.87. What is the difference between the highest and the lowest Amount(% of total) of Trinidad and Tobago?
Your answer should be compact. 4.04. 